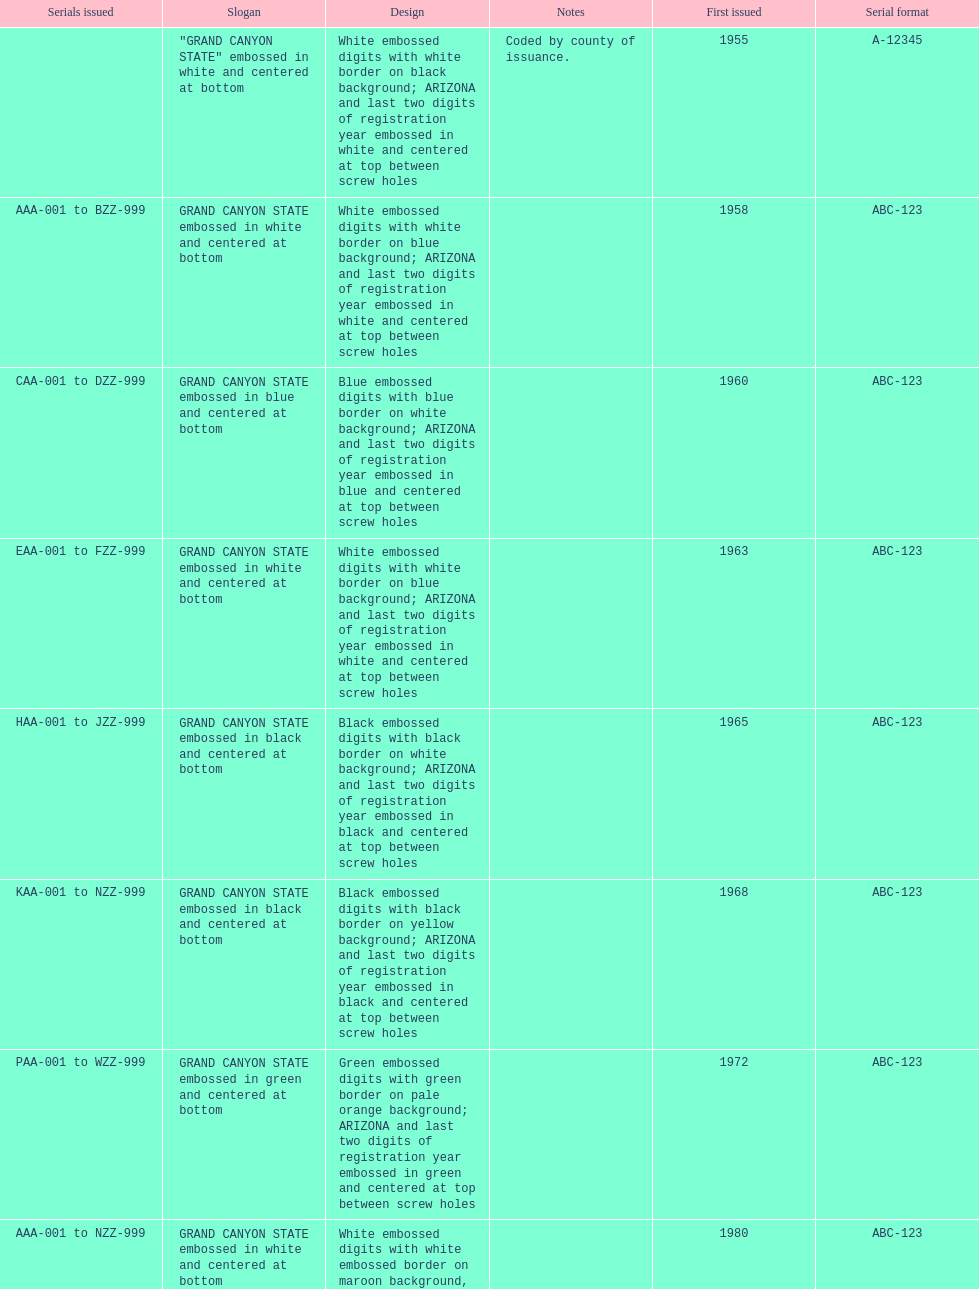What is the average serial format of the arizona license plates? ABC-123. 